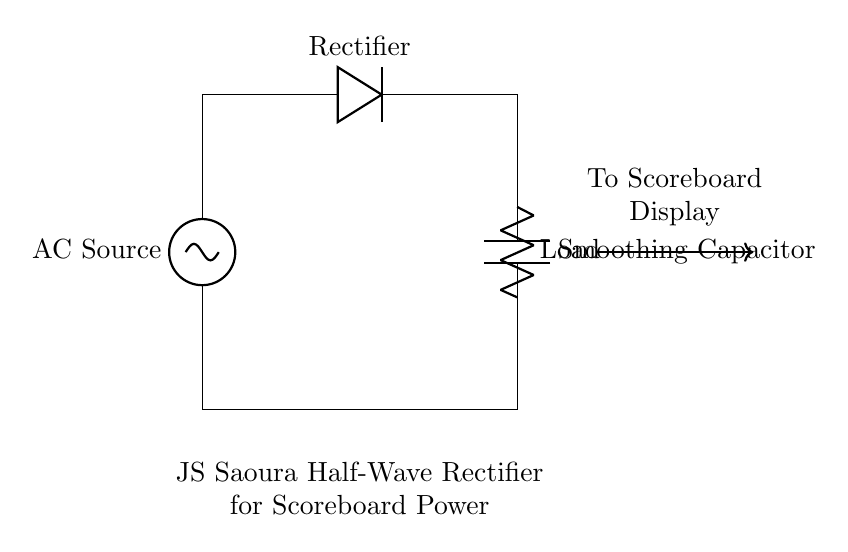What type of rectifier is shown in this circuit? The circuit features a half-wave rectifier, as indicated by the presence of a single diode that allows current to pass through only during one half of the AC cycle.
Answer: half-wave rectifier What is the purpose of the smoothing capacitor? The smoothing capacitor is used to reduce voltage fluctuations and provide a more stable DC output, which is essential for the consistent operation of the scoreboard display.
Answer: stabilize voltage How many diodes are present in this circuit? There is one diode in the circuit, which is a key component of the half-wave rectifier that allows current to flow in one direction only.
Answer: one What is the output of this rectifier circuit? The output is a pulsating DC voltage that varies with the input AC signal, but the smoothing capacitor helps in averaging this to a steadier voltage level.
Answer: pulsating DC What is connected to the output of this circuit? The output is connected to the scoreboard display, which requires a power supply that is compatible with its operational voltage specifications.
Answer: scoreboard display What does the load resistor represent in this circuit? The load resistor represents the actual device that consumes power, which in this case is the scoreboard display that needs electrical energy to function.
Answer: load How does the rectifier affect the AC input voltage? The rectifier converts the AC input voltage into a DC output voltage, allowing only the positive half of the AC waveform to pass through while blocking the negative half.
Answer: converts AC to DC 